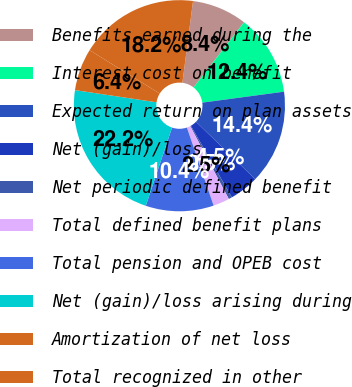Convert chart to OTSL. <chart><loc_0><loc_0><loc_500><loc_500><pie_chart><fcel>Benefits earned during the<fcel>Interest cost on benefit<fcel>Expected return on plan assets<fcel>Net (gain)/loss<fcel>Net periodic defined benefit<fcel>Total defined benefit plans<fcel>Total pension and OPEB cost<fcel>Net (gain)/loss arising during<fcel>Amortization of net loss<fcel>Total recognized in other<nl><fcel>8.43%<fcel>12.39%<fcel>14.37%<fcel>4.48%<fcel>0.52%<fcel>2.5%<fcel>10.41%<fcel>22.2%<fcel>6.45%<fcel>18.25%<nl></chart> 